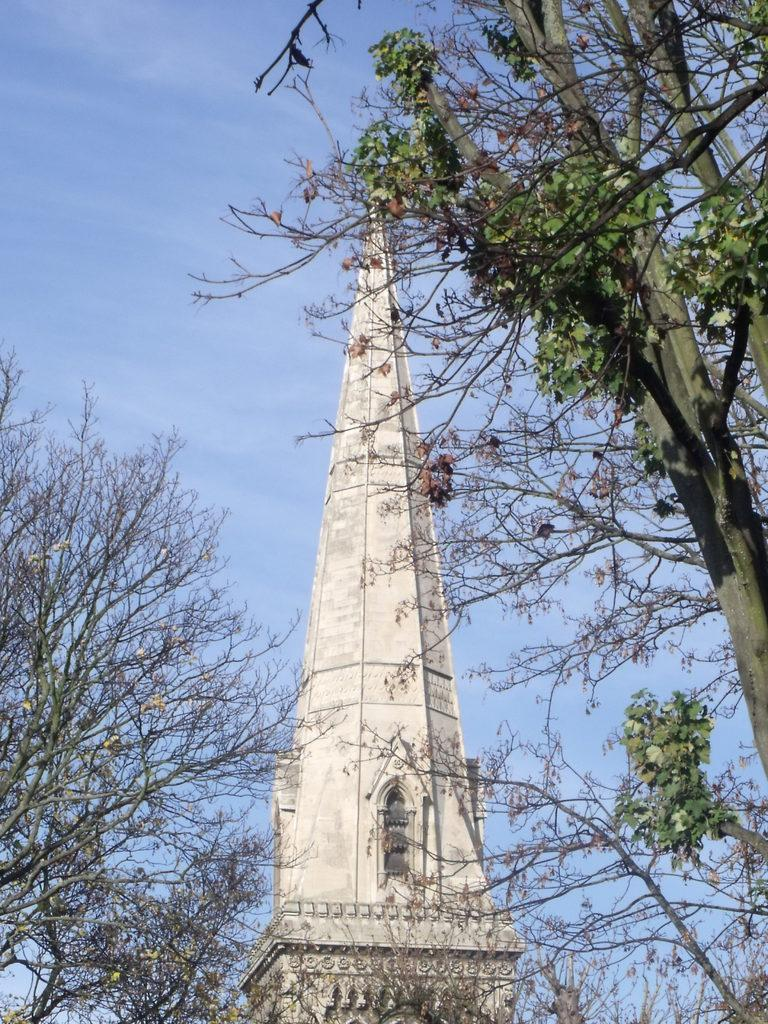What type of natural elements can be seen in the image? There are trees in the image. What type of man-made structure is present in the image? There is a building in the image. What is visible in the background of the image? The sky is visible in the background of the image. Can you see any notes being passed between the trees in the image? There are no notes or any indication of communication between the trees in the image. Is there a mine visible in the image? There is no mine present in the image; it features trees and a building. 